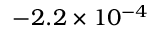<formula> <loc_0><loc_0><loc_500><loc_500>- 2 . 2 \times 1 0 ^ { - 4 }</formula> 